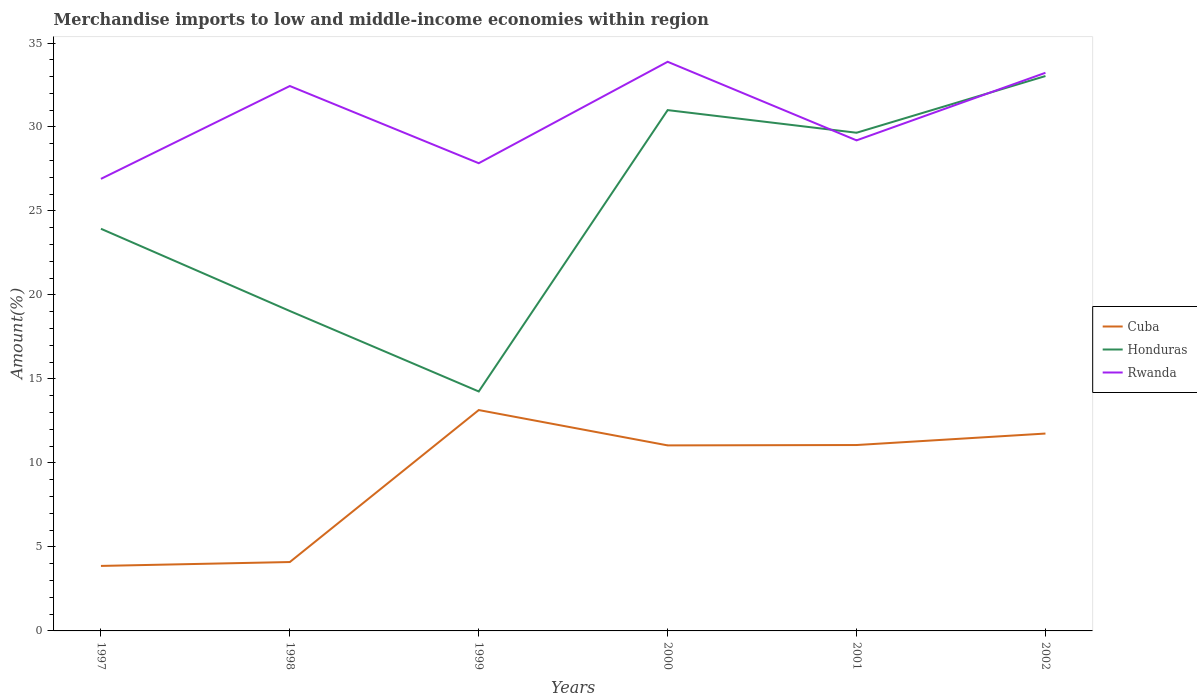How many different coloured lines are there?
Provide a short and direct response. 3. Is the number of lines equal to the number of legend labels?
Offer a terse response. Yes. Across all years, what is the maximum percentage of amount earned from merchandise imports in Rwanda?
Provide a succinct answer. 26.91. In which year was the percentage of amount earned from merchandise imports in Rwanda maximum?
Your answer should be compact. 1997. What is the total percentage of amount earned from merchandise imports in Honduras in the graph?
Your answer should be very brief. -10.61. What is the difference between the highest and the second highest percentage of amount earned from merchandise imports in Cuba?
Your response must be concise. 9.28. What is the difference between the highest and the lowest percentage of amount earned from merchandise imports in Cuba?
Keep it short and to the point. 4. Is the percentage of amount earned from merchandise imports in Cuba strictly greater than the percentage of amount earned from merchandise imports in Rwanda over the years?
Offer a very short reply. Yes. How many lines are there?
Offer a terse response. 3. How many years are there in the graph?
Your answer should be compact. 6. What is the difference between two consecutive major ticks on the Y-axis?
Offer a very short reply. 5. Does the graph contain grids?
Ensure brevity in your answer.  No. What is the title of the graph?
Offer a very short reply. Merchandise imports to low and middle-income economies within region. Does "Niger" appear as one of the legend labels in the graph?
Provide a short and direct response. No. What is the label or title of the Y-axis?
Offer a very short reply. Amount(%). What is the Amount(%) of Cuba in 1997?
Your answer should be very brief. 3.87. What is the Amount(%) in Honduras in 1997?
Your answer should be very brief. 23.94. What is the Amount(%) in Rwanda in 1997?
Provide a short and direct response. 26.91. What is the Amount(%) of Cuba in 1998?
Offer a very short reply. 4.1. What is the Amount(%) of Honduras in 1998?
Provide a succinct answer. 19.05. What is the Amount(%) of Rwanda in 1998?
Your answer should be compact. 32.44. What is the Amount(%) of Cuba in 1999?
Give a very brief answer. 13.15. What is the Amount(%) in Honduras in 1999?
Your response must be concise. 14.26. What is the Amount(%) of Rwanda in 1999?
Ensure brevity in your answer.  27.84. What is the Amount(%) in Cuba in 2000?
Your response must be concise. 11.05. What is the Amount(%) of Honduras in 2000?
Provide a short and direct response. 31.01. What is the Amount(%) of Rwanda in 2000?
Your answer should be compact. 33.88. What is the Amount(%) of Cuba in 2001?
Your answer should be compact. 11.07. What is the Amount(%) of Honduras in 2001?
Ensure brevity in your answer.  29.66. What is the Amount(%) in Rwanda in 2001?
Keep it short and to the point. 29.2. What is the Amount(%) in Cuba in 2002?
Provide a succinct answer. 11.75. What is the Amount(%) in Honduras in 2002?
Make the answer very short. 33.03. What is the Amount(%) in Rwanda in 2002?
Ensure brevity in your answer.  33.23. Across all years, what is the maximum Amount(%) of Cuba?
Offer a terse response. 13.15. Across all years, what is the maximum Amount(%) in Honduras?
Keep it short and to the point. 33.03. Across all years, what is the maximum Amount(%) in Rwanda?
Ensure brevity in your answer.  33.88. Across all years, what is the minimum Amount(%) in Cuba?
Your answer should be very brief. 3.87. Across all years, what is the minimum Amount(%) of Honduras?
Provide a succinct answer. 14.26. Across all years, what is the minimum Amount(%) in Rwanda?
Make the answer very short. 26.91. What is the total Amount(%) of Cuba in the graph?
Keep it short and to the point. 54.98. What is the total Amount(%) of Honduras in the graph?
Make the answer very short. 150.94. What is the total Amount(%) of Rwanda in the graph?
Your response must be concise. 183.51. What is the difference between the Amount(%) of Cuba in 1997 and that in 1998?
Offer a terse response. -0.23. What is the difference between the Amount(%) of Honduras in 1997 and that in 1998?
Your answer should be very brief. 4.9. What is the difference between the Amount(%) in Rwanda in 1997 and that in 1998?
Offer a very short reply. -5.53. What is the difference between the Amount(%) in Cuba in 1997 and that in 1999?
Make the answer very short. -9.28. What is the difference between the Amount(%) of Honduras in 1997 and that in 1999?
Give a very brief answer. 9.69. What is the difference between the Amount(%) in Rwanda in 1997 and that in 1999?
Offer a terse response. -0.93. What is the difference between the Amount(%) in Cuba in 1997 and that in 2000?
Give a very brief answer. -7.18. What is the difference between the Amount(%) in Honduras in 1997 and that in 2000?
Provide a succinct answer. -7.06. What is the difference between the Amount(%) in Rwanda in 1997 and that in 2000?
Provide a short and direct response. -6.97. What is the difference between the Amount(%) of Cuba in 1997 and that in 2001?
Your answer should be very brief. -7.2. What is the difference between the Amount(%) of Honduras in 1997 and that in 2001?
Make the answer very short. -5.72. What is the difference between the Amount(%) of Rwanda in 1997 and that in 2001?
Provide a short and direct response. -2.29. What is the difference between the Amount(%) in Cuba in 1997 and that in 2002?
Provide a succinct answer. -7.88. What is the difference between the Amount(%) of Honduras in 1997 and that in 2002?
Provide a short and direct response. -9.09. What is the difference between the Amount(%) of Rwanda in 1997 and that in 2002?
Give a very brief answer. -6.32. What is the difference between the Amount(%) of Cuba in 1998 and that in 1999?
Make the answer very short. -9.05. What is the difference between the Amount(%) of Honduras in 1998 and that in 1999?
Offer a very short reply. 4.79. What is the difference between the Amount(%) in Rwanda in 1998 and that in 1999?
Provide a short and direct response. 4.6. What is the difference between the Amount(%) in Cuba in 1998 and that in 2000?
Your response must be concise. -6.94. What is the difference between the Amount(%) of Honduras in 1998 and that in 2000?
Give a very brief answer. -11.96. What is the difference between the Amount(%) in Rwanda in 1998 and that in 2000?
Provide a succinct answer. -1.44. What is the difference between the Amount(%) of Cuba in 1998 and that in 2001?
Provide a short and direct response. -6.97. What is the difference between the Amount(%) of Honduras in 1998 and that in 2001?
Provide a succinct answer. -10.61. What is the difference between the Amount(%) in Rwanda in 1998 and that in 2001?
Provide a succinct answer. 3.24. What is the difference between the Amount(%) in Cuba in 1998 and that in 2002?
Provide a short and direct response. -7.65. What is the difference between the Amount(%) in Honduras in 1998 and that in 2002?
Provide a short and direct response. -13.99. What is the difference between the Amount(%) of Rwanda in 1998 and that in 2002?
Make the answer very short. -0.79. What is the difference between the Amount(%) in Cuba in 1999 and that in 2000?
Keep it short and to the point. 2.1. What is the difference between the Amount(%) of Honduras in 1999 and that in 2000?
Your response must be concise. -16.75. What is the difference between the Amount(%) in Rwanda in 1999 and that in 2000?
Offer a very short reply. -6.04. What is the difference between the Amount(%) of Cuba in 1999 and that in 2001?
Ensure brevity in your answer.  2.08. What is the difference between the Amount(%) in Honduras in 1999 and that in 2001?
Your answer should be very brief. -15.4. What is the difference between the Amount(%) of Rwanda in 1999 and that in 2001?
Provide a succinct answer. -1.36. What is the difference between the Amount(%) in Cuba in 1999 and that in 2002?
Your response must be concise. 1.4. What is the difference between the Amount(%) in Honduras in 1999 and that in 2002?
Your response must be concise. -18.78. What is the difference between the Amount(%) of Rwanda in 1999 and that in 2002?
Provide a short and direct response. -5.38. What is the difference between the Amount(%) of Cuba in 2000 and that in 2001?
Offer a very short reply. -0.02. What is the difference between the Amount(%) of Honduras in 2000 and that in 2001?
Make the answer very short. 1.35. What is the difference between the Amount(%) of Rwanda in 2000 and that in 2001?
Provide a short and direct response. 4.68. What is the difference between the Amount(%) in Cuba in 2000 and that in 2002?
Your response must be concise. -0.71. What is the difference between the Amount(%) of Honduras in 2000 and that in 2002?
Your answer should be compact. -2.03. What is the difference between the Amount(%) of Rwanda in 2000 and that in 2002?
Provide a succinct answer. 0.66. What is the difference between the Amount(%) of Cuba in 2001 and that in 2002?
Provide a short and direct response. -0.68. What is the difference between the Amount(%) in Honduras in 2001 and that in 2002?
Make the answer very short. -3.38. What is the difference between the Amount(%) in Rwanda in 2001 and that in 2002?
Make the answer very short. -4.02. What is the difference between the Amount(%) of Cuba in 1997 and the Amount(%) of Honduras in 1998?
Give a very brief answer. -15.18. What is the difference between the Amount(%) in Cuba in 1997 and the Amount(%) in Rwanda in 1998?
Keep it short and to the point. -28.57. What is the difference between the Amount(%) in Honduras in 1997 and the Amount(%) in Rwanda in 1998?
Your answer should be compact. -8.5. What is the difference between the Amount(%) of Cuba in 1997 and the Amount(%) of Honduras in 1999?
Make the answer very short. -10.39. What is the difference between the Amount(%) in Cuba in 1997 and the Amount(%) in Rwanda in 1999?
Provide a succinct answer. -23.97. What is the difference between the Amount(%) of Honduras in 1997 and the Amount(%) of Rwanda in 1999?
Offer a terse response. -3.9. What is the difference between the Amount(%) of Cuba in 1997 and the Amount(%) of Honduras in 2000?
Make the answer very short. -27.14. What is the difference between the Amount(%) in Cuba in 1997 and the Amount(%) in Rwanda in 2000?
Offer a terse response. -30.01. What is the difference between the Amount(%) in Honduras in 1997 and the Amount(%) in Rwanda in 2000?
Provide a short and direct response. -9.94. What is the difference between the Amount(%) of Cuba in 1997 and the Amount(%) of Honduras in 2001?
Ensure brevity in your answer.  -25.79. What is the difference between the Amount(%) in Cuba in 1997 and the Amount(%) in Rwanda in 2001?
Provide a succinct answer. -25.33. What is the difference between the Amount(%) in Honduras in 1997 and the Amount(%) in Rwanda in 2001?
Give a very brief answer. -5.26. What is the difference between the Amount(%) in Cuba in 1997 and the Amount(%) in Honduras in 2002?
Make the answer very short. -29.16. What is the difference between the Amount(%) in Cuba in 1997 and the Amount(%) in Rwanda in 2002?
Your answer should be very brief. -29.36. What is the difference between the Amount(%) in Honduras in 1997 and the Amount(%) in Rwanda in 2002?
Offer a very short reply. -9.29. What is the difference between the Amount(%) of Cuba in 1998 and the Amount(%) of Honduras in 1999?
Provide a short and direct response. -10.15. What is the difference between the Amount(%) in Cuba in 1998 and the Amount(%) in Rwanda in 1999?
Ensure brevity in your answer.  -23.74. What is the difference between the Amount(%) in Honduras in 1998 and the Amount(%) in Rwanda in 1999?
Offer a terse response. -8.8. What is the difference between the Amount(%) of Cuba in 1998 and the Amount(%) of Honduras in 2000?
Make the answer very short. -26.9. What is the difference between the Amount(%) of Cuba in 1998 and the Amount(%) of Rwanda in 2000?
Your answer should be very brief. -29.78. What is the difference between the Amount(%) in Honduras in 1998 and the Amount(%) in Rwanda in 2000?
Make the answer very short. -14.84. What is the difference between the Amount(%) in Cuba in 1998 and the Amount(%) in Honduras in 2001?
Keep it short and to the point. -25.56. What is the difference between the Amount(%) in Cuba in 1998 and the Amount(%) in Rwanda in 2001?
Give a very brief answer. -25.1. What is the difference between the Amount(%) in Honduras in 1998 and the Amount(%) in Rwanda in 2001?
Offer a very short reply. -10.16. What is the difference between the Amount(%) of Cuba in 1998 and the Amount(%) of Honduras in 2002?
Ensure brevity in your answer.  -28.93. What is the difference between the Amount(%) of Cuba in 1998 and the Amount(%) of Rwanda in 2002?
Provide a short and direct response. -29.13. What is the difference between the Amount(%) of Honduras in 1998 and the Amount(%) of Rwanda in 2002?
Provide a short and direct response. -14.18. What is the difference between the Amount(%) of Cuba in 1999 and the Amount(%) of Honduras in 2000?
Give a very brief answer. -17.86. What is the difference between the Amount(%) in Cuba in 1999 and the Amount(%) in Rwanda in 2000?
Ensure brevity in your answer.  -20.73. What is the difference between the Amount(%) of Honduras in 1999 and the Amount(%) of Rwanda in 2000?
Provide a succinct answer. -19.63. What is the difference between the Amount(%) of Cuba in 1999 and the Amount(%) of Honduras in 2001?
Keep it short and to the point. -16.51. What is the difference between the Amount(%) of Cuba in 1999 and the Amount(%) of Rwanda in 2001?
Your answer should be compact. -16.06. What is the difference between the Amount(%) in Honduras in 1999 and the Amount(%) in Rwanda in 2001?
Your answer should be compact. -14.95. What is the difference between the Amount(%) in Cuba in 1999 and the Amount(%) in Honduras in 2002?
Offer a very short reply. -19.88. What is the difference between the Amount(%) in Cuba in 1999 and the Amount(%) in Rwanda in 2002?
Provide a succinct answer. -20.08. What is the difference between the Amount(%) in Honduras in 1999 and the Amount(%) in Rwanda in 2002?
Make the answer very short. -18.97. What is the difference between the Amount(%) in Cuba in 2000 and the Amount(%) in Honduras in 2001?
Offer a very short reply. -18.61. What is the difference between the Amount(%) of Cuba in 2000 and the Amount(%) of Rwanda in 2001?
Your answer should be compact. -18.16. What is the difference between the Amount(%) of Honduras in 2000 and the Amount(%) of Rwanda in 2001?
Ensure brevity in your answer.  1.8. What is the difference between the Amount(%) of Cuba in 2000 and the Amount(%) of Honduras in 2002?
Provide a succinct answer. -21.99. What is the difference between the Amount(%) of Cuba in 2000 and the Amount(%) of Rwanda in 2002?
Offer a very short reply. -22.18. What is the difference between the Amount(%) in Honduras in 2000 and the Amount(%) in Rwanda in 2002?
Keep it short and to the point. -2.22. What is the difference between the Amount(%) in Cuba in 2001 and the Amount(%) in Honduras in 2002?
Your answer should be compact. -21.97. What is the difference between the Amount(%) of Cuba in 2001 and the Amount(%) of Rwanda in 2002?
Make the answer very short. -22.16. What is the difference between the Amount(%) in Honduras in 2001 and the Amount(%) in Rwanda in 2002?
Provide a short and direct response. -3.57. What is the average Amount(%) of Cuba per year?
Provide a succinct answer. 9.16. What is the average Amount(%) of Honduras per year?
Offer a very short reply. 25.16. What is the average Amount(%) of Rwanda per year?
Provide a succinct answer. 30.58. In the year 1997, what is the difference between the Amount(%) of Cuba and Amount(%) of Honduras?
Offer a terse response. -20.07. In the year 1997, what is the difference between the Amount(%) of Cuba and Amount(%) of Rwanda?
Offer a terse response. -23.04. In the year 1997, what is the difference between the Amount(%) in Honduras and Amount(%) in Rwanda?
Provide a succinct answer. -2.97. In the year 1998, what is the difference between the Amount(%) of Cuba and Amount(%) of Honduras?
Your response must be concise. -14.94. In the year 1998, what is the difference between the Amount(%) of Cuba and Amount(%) of Rwanda?
Give a very brief answer. -28.34. In the year 1998, what is the difference between the Amount(%) in Honduras and Amount(%) in Rwanda?
Offer a terse response. -13.39. In the year 1999, what is the difference between the Amount(%) in Cuba and Amount(%) in Honduras?
Offer a very short reply. -1.11. In the year 1999, what is the difference between the Amount(%) in Cuba and Amount(%) in Rwanda?
Provide a succinct answer. -14.7. In the year 1999, what is the difference between the Amount(%) of Honduras and Amount(%) of Rwanda?
Give a very brief answer. -13.59. In the year 2000, what is the difference between the Amount(%) of Cuba and Amount(%) of Honduras?
Provide a short and direct response. -19.96. In the year 2000, what is the difference between the Amount(%) in Cuba and Amount(%) in Rwanda?
Provide a succinct answer. -22.84. In the year 2000, what is the difference between the Amount(%) of Honduras and Amount(%) of Rwanda?
Provide a short and direct response. -2.88. In the year 2001, what is the difference between the Amount(%) in Cuba and Amount(%) in Honduras?
Your response must be concise. -18.59. In the year 2001, what is the difference between the Amount(%) of Cuba and Amount(%) of Rwanda?
Your answer should be compact. -18.14. In the year 2001, what is the difference between the Amount(%) of Honduras and Amount(%) of Rwanda?
Your answer should be very brief. 0.45. In the year 2002, what is the difference between the Amount(%) of Cuba and Amount(%) of Honduras?
Offer a very short reply. -21.28. In the year 2002, what is the difference between the Amount(%) in Cuba and Amount(%) in Rwanda?
Provide a succinct answer. -21.48. In the year 2002, what is the difference between the Amount(%) in Honduras and Amount(%) in Rwanda?
Keep it short and to the point. -0.19. What is the ratio of the Amount(%) of Cuba in 1997 to that in 1998?
Your answer should be very brief. 0.94. What is the ratio of the Amount(%) of Honduras in 1997 to that in 1998?
Offer a very short reply. 1.26. What is the ratio of the Amount(%) in Rwanda in 1997 to that in 1998?
Offer a very short reply. 0.83. What is the ratio of the Amount(%) in Cuba in 1997 to that in 1999?
Your answer should be very brief. 0.29. What is the ratio of the Amount(%) in Honduras in 1997 to that in 1999?
Ensure brevity in your answer.  1.68. What is the ratio of the Amount(%) in Rwanda in 1997 to that in 1999?
Keep it short and to the point. 0.97. What is the ratio of the Amount(%) in Cuba in 1997 to that in 2000?
Provide a short and direct response. 0.35. What is the ratio of the Amount(%) in Honduras in 1997 to that in 2000?
Make the answer very short. 0.77. What is the ratio of the Amount(%) of Rwanda in 1997 to that in 2000?
Keep it short and to the point. 0.79. What is the ratio of the Amount(%) in Cuba in 1997 to that in 2001?
Your answer should be compact. 0.35. What is the ratio of the Amount(%) of Honduras in 1997 to that in 2001?
Ensure brevity in your answer.  0.81. What is the ratio of the Amount(%) in Rwanda in 1997 to that in 2001?
Give a very brief answer. 0.92. What is the ratio of the Amount(%) in Cuba in 1997 to that in 2002?
Give a very brief answer. 0.33. What is the ratio of the Amount(%) in Honduras in 1997 to that in 2002?
Your response must be concise. 0.72. What is the ratio of the Amount(%) of Rwanda in 1997 to that in 2002?
Your answer should be very brief. 0.81. What is the ratio of the Amount(%) of Cuba in 1998 to that in 1999?
Your response must be concise. 0.31. What is the ratio of the Amount(%) of Honduras in 1998 to that in 1999?
Offer a very short reply. 1.34. What is the ratio of the Amount(%) in Rwanda in 1998 to that in 1999?
Provide a succinct answer. 1.17. What is the ratio of the Amount(%) of Cuba in 1998 to that in 2000?
Your answer should be very brief. 0.37. What is the ratio of the Amount(%) in Honduras in 1998 to that in 2000?
Make the answer very short. 0.61. What is the ratio of the Amount(%) in Rwanda in 1998 to that in 2000?
Give a very brief answer. 0.96. What is the ratio of the Amount(%) of Cuba in 1998 to that in 2001?
Provide a succinct answer. 0.37. What is the ratio of the Amount(%) in Honduras in 1998 to that in 2001?
Provide a short and direct response. 0.64. What is the ratio of the Amount(%) in Rwanda in 1998 to that in 2001?
Your answer should be compact. 1.11. What is the ratio of the Amount(%) in Cuba in 1998 to that in 2002?
Your answer should be very brief. 0.35. What is the ratio of the Amount(%) in Honduras in 1998 to that in 2002?
Keep it short and to the point. 0.58. What is the ratio of the Amount(%) of Rwanda in 1998 to that in 2002?
Give a very brief answer. 0.98. What is the ratio of the Amount(%) of Cuba in 1999 to that in 2000?
Provide a short and direct response. 1.19. What is the ratio of the Amount(%) of Honduras in 1999 to that in 2000?
Keep it short and to the point. 0.46. What is the ratio of the Amount(%) of Rwanda in 1999 to that in 2000?
Make the answer very short. 0.82. What is the ratio of the Amount(%) of Cuba in 1999 to that in 2001?
Provide a short and direct response. 1.19. What is the ratio of the Amount(%) of Honduras in 1999 to that in 2001?
Offer a terse response. 0.48. What is the ratio of the Amount(%) in Rwanda in 1999 to that in 2001?
Your answer should be very brief. 0.95. What is the ratio of the Amount(%) in Cuba in 1999 to that in 2002?
Make the answer very short. 1.12. What is the ratio of the Amount(%) of Honduras in 1999 to that in 2002?
Your answer should be very brief. 0.43. What is the ratio of the Amount(%) of Rwanda in 1999 to that in 2002?
Offer a terse response. 0.84. What is the ratio of the Amount(%) in Cuba in 2000 to that in 2001?
Provide a succinct answer. 1. What is the ratio of the Amount(%) of Honduras in 2000 to that in 2001?
Your answer should be compact. 1.05. What is the ratio of the Amount(%) in Rwanda in 2000 to that in 2001?
Your answer should be compact. 1.16. What is the ratio of the Amount(%) in Honduras in 2000 to that in 2002?
Provide a short and direct response. 0.94. What is the ratio of the Amount(%) of Rwanda in 2000 to that in 2002?
Your answer should be very brief. 1.02. What is the ratio of the Amount(%) of Cuba in 2001 to that in 2002?
Your answer should be compact. 0.94. What is the ratio of the Amount(%) of Honduras in 2001 to that in 2002?
Make the answer very short. 0.9. What is the ratio of the Amount(%) in Rwanda in 2001 to that in 2002?
Offer a very short reply. 0.88. What is the difference between the highest and the second highest Amount(%) of Cuba?
Ensure brevity in your answer.  1.4. What is the difference between the highest and the second highest Amount(%) of Honduras?
Offer a very short reply. 2.03. What is the difference between the highest and the second highest Amount(%) in Rwanda?
Ensure brevity in your answer.  0.66. What is the difference between the highest and the lowest Amount(%) in Cuba?
Provide a short and direct response. 9.28. What is the difference between the highest and the lowest Amount(%) of Honduras?
Your answer should be very brief. 18.78. What is the difference between the highest and the lowest Amount(%) of Rwanda?
Give a very brief answer. 6.97. 